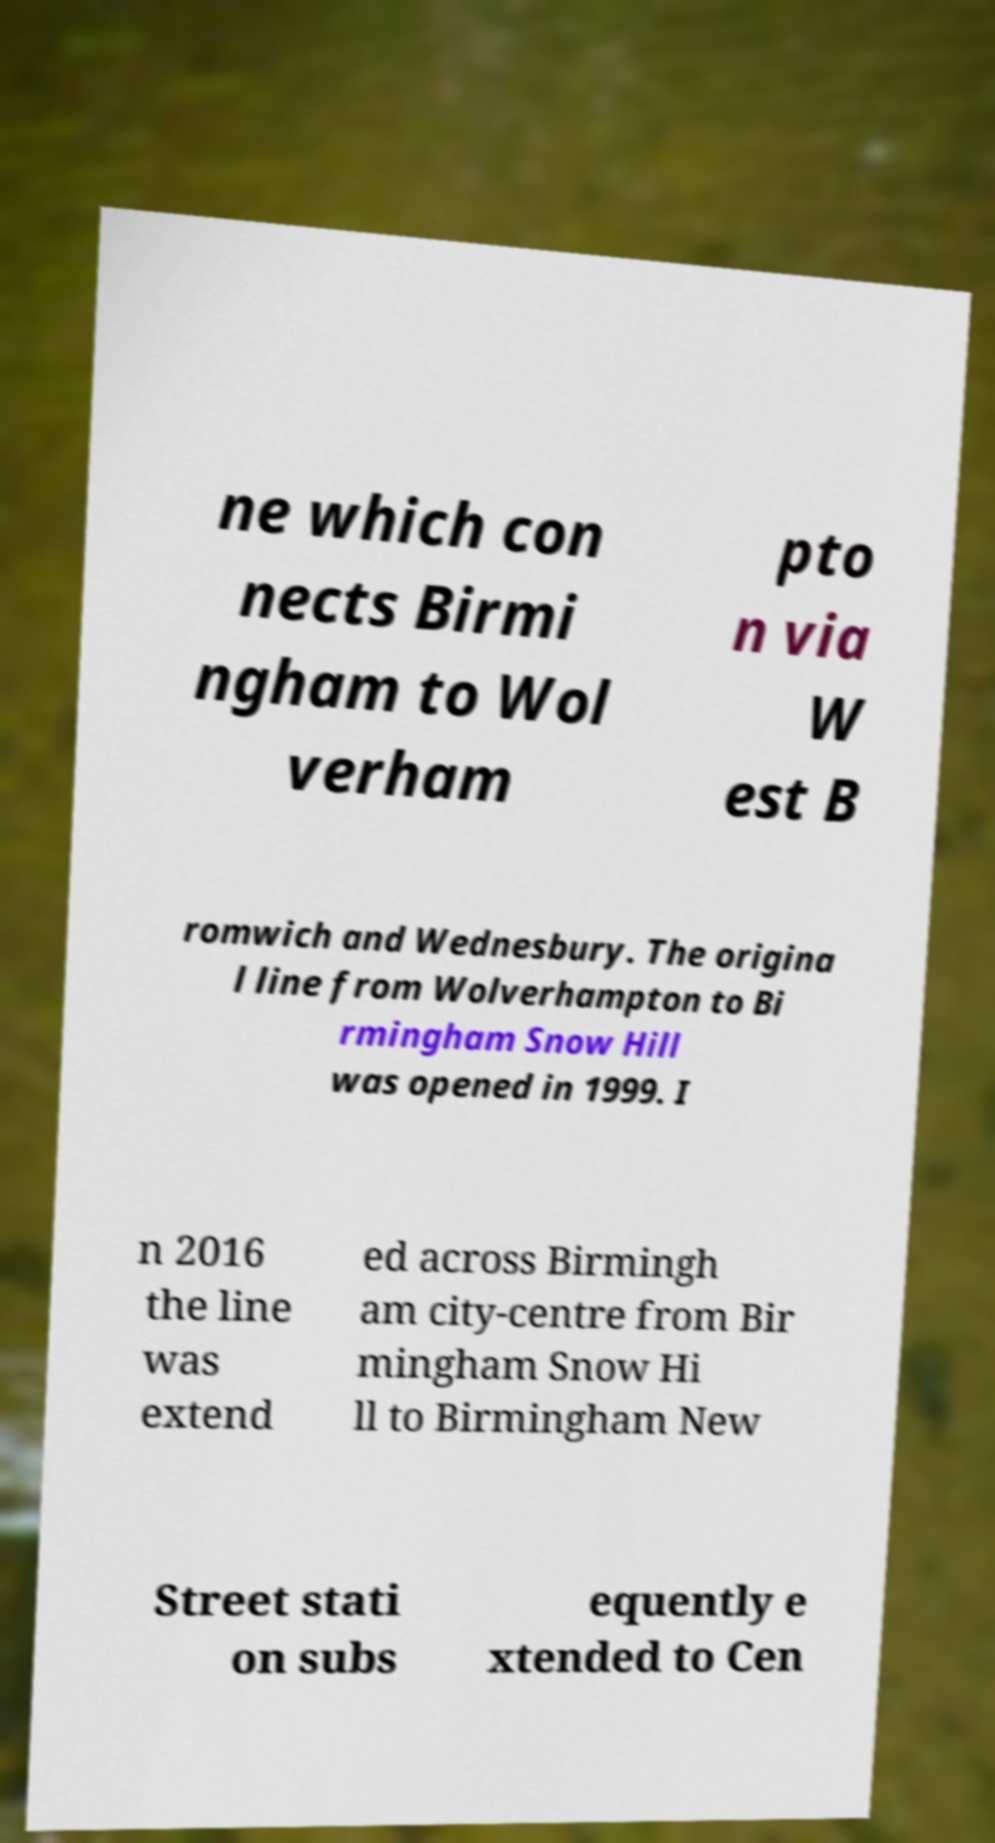Could you extract and type out the text from this image? ne which con nects Birmi ngham to Wol verham pto n via W est B romwich and Wednesbury. The origina l line from Wolverhampton to Bi rmingham Snow Hill was opened in 1999. I n 2016 the line was extend ed across Birmingh am city-centre from Bir mingham Snow Hi ll to Birmingham New Street stati on subs equently e xtended to Cen 